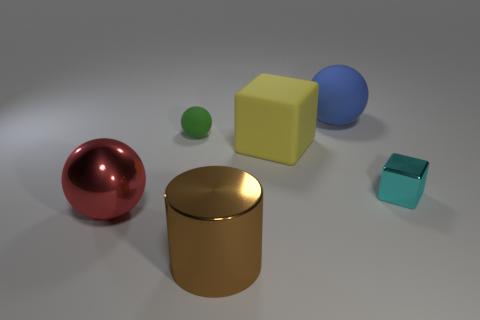Subtract all big spheres. How many spheres are left? 1 Add 1 big cyan metal cylinders. How many objects exist? 7 Subtract all red balls. How many balls are left? 2 Subtract all cylinders. How many objects are left? 5 Subtract all blue balls. Subtract all blocks. How many objects are left? 3 Add 6 brown things. How many brown things are left? 7 Add 6 big blue rubber balls. How many big blue rubber balls exist? 7 Subtract 0 blue cylinders. How many objects are left? 6 Subtract all purple cubes. Subtract all brown cylinders. How many cubes are left? 2 